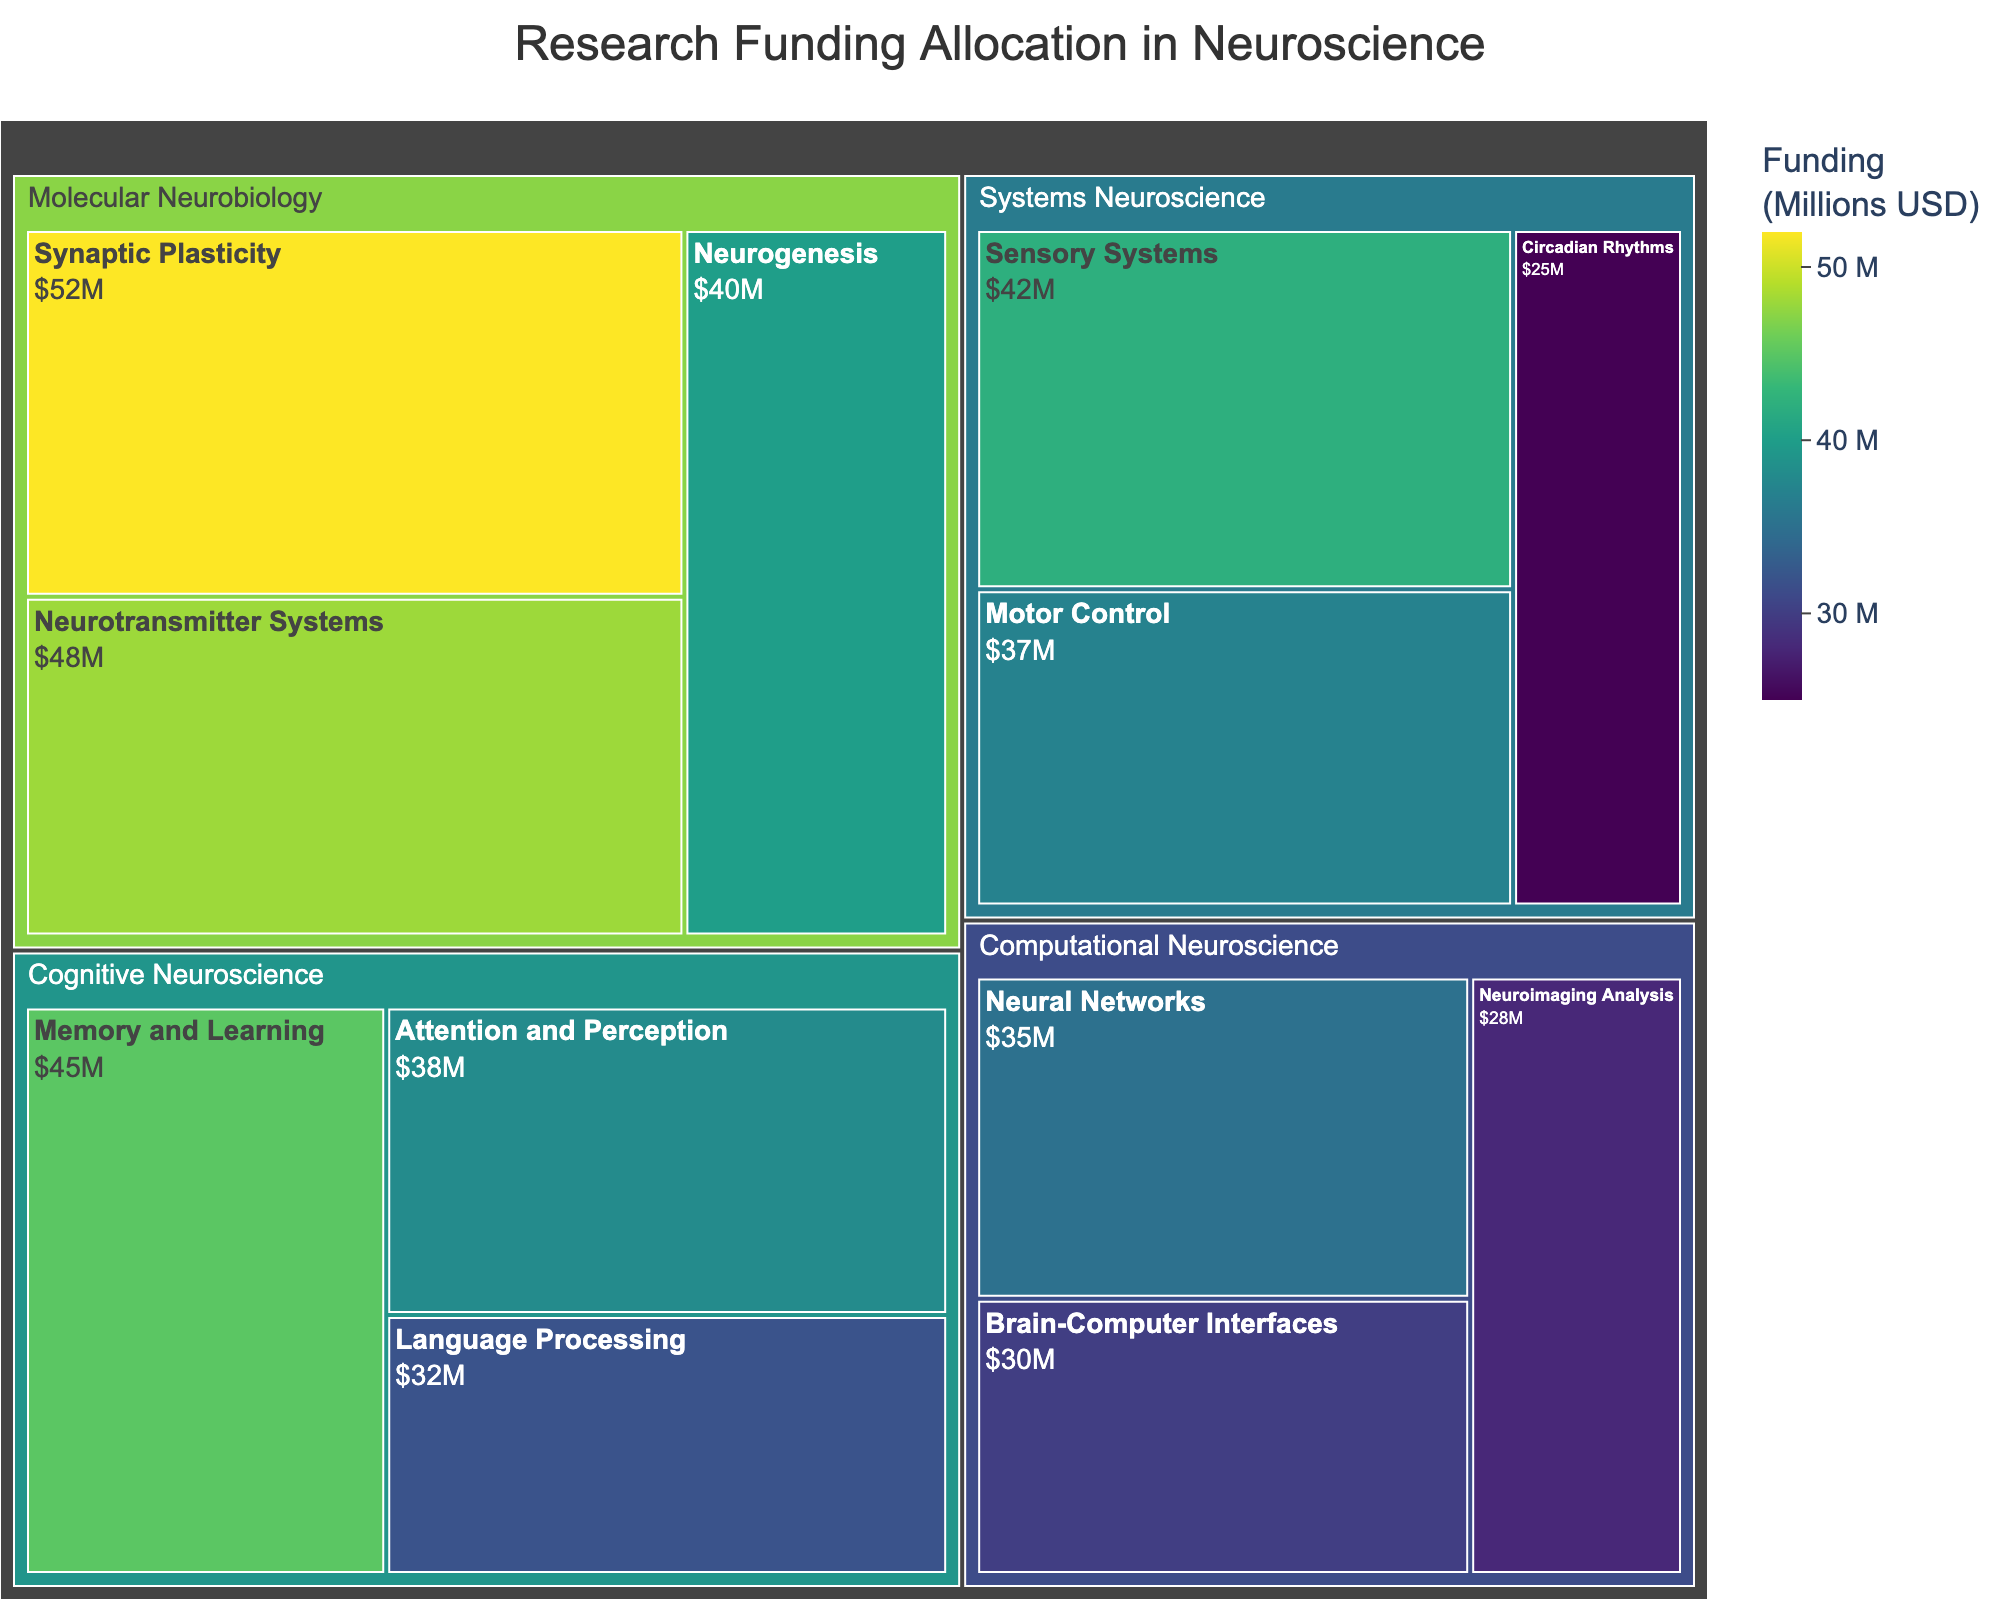What is the title of the treemap? The title of the treemap is usually located at the top center of the figure, making it easy to identify the general topic of the visualized data.
Answer: Research Funding Allocation in Neuroscience Which subarea received the highest research funding in Molecular Neurobiology? In the Molecular Neurobiology area, the subarea with the highest funding can be identified by the largest section within its segment.
Answer: Synaptic Plasticity Which area has the lowest total funding among all areas shown? To determine the area with the lowest total funding, sum the funding amounts for each subarea within each area, then compare the totals. Computational Neuroscience has lower total funding compared to Cognitive Neuroscience, Molecular Neurobiology, and Systems Neuroscience.
Answer: Computational Neuroscience How much funding is allocated to Memory and Learning in Cognitive Neuroscience? The funding for Memory and Learning in Cognitive Neuroscience is directly indicated within its respective rectangle in the treemap.
Answer: 45 million USD What is the combined funding for Neurogenesis and Neurotransmitter Systems in Molecular Neurobiology? The combined funding for Neurogenesis and Neurotransmitter Systems can be found by adding their individual funding amounts: 40 + 48.
Answer: 88 million USD Which subarea in Cognitive Neuroscience received less funding: Attention and Perception or Language Processing? Compare the funding amounts for the Attention and Perception and Language Processing subareas within Cognitive Neuroscience to see which one is smaller.
Answer: Language Processing How does the funding for Synaptic Plasticity compare to Brain-Computer Interfaces? Compare the funding amounts for Synaptic Plasticity in Molecular Neurobiology and Brain-Computer Interfaces in Computational Neuroscience to identify which is higher.
Answer: Synaptic Plasticity received more funding What is the total funding allocated to Systems Neuroscience? To find the total funding for Systems Neuroscience, sum the funding amounts for Sensory Systems, Motor Control, and Circadian Rhythms: 42 + 37 + 25.
Answer: 104 million USD How much more funding is allocated to Neural Networks compared to Neuroimaging Analysis in Computational Neuroscience? Subtract the funding amount for Neuroimaging Analysis from the funding amount for Neural Networks to find the difference: 35 - 28.
Answer: 7 million USD 